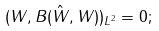<formula> <loc_0><loc_0><loc_500><loc_500>( W , B ( \hat { W } , W ) ) _ { L ^ { 2 } } = 0 ;</formula> 